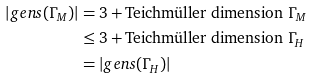<formula> <loc_0><loc_0><loc_500><loc_500>\left | g e n s ( \Gamma _ { M } ) \right | & = 3 + \text {Teichm\"{u}ller dimension } \Gamma _ { M } \\ & \leq 3 + \text {Teichm\"{u}ller dimension } \Gamma _ { H } \\ & = \left | g e n s ( \Gamma _ { H } ) \right |</formula> 